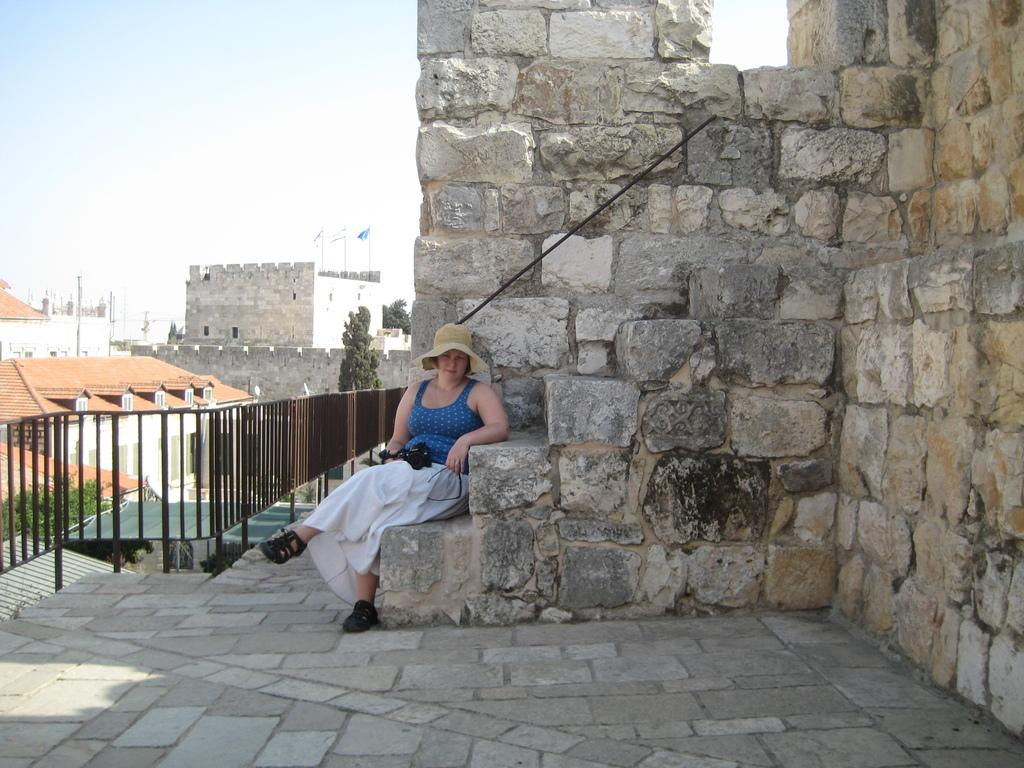Who is the main subject in the image? There is a woman in the image. What is the woman holding in the image? The woman is holding a camera. Where is the woman sitting in the image? The woman is sitting on rock stairs. What can be seen behind the woman in the image? There are rocks, a metal fence, trees, and buildings behind the woman. What is on the buildings behind the woman? Flags are present on the buildings. What type of lunch is the woman eating in the image? There is no indication in the image that the woman is eating lunch, so it cannot be determined from the picture. 